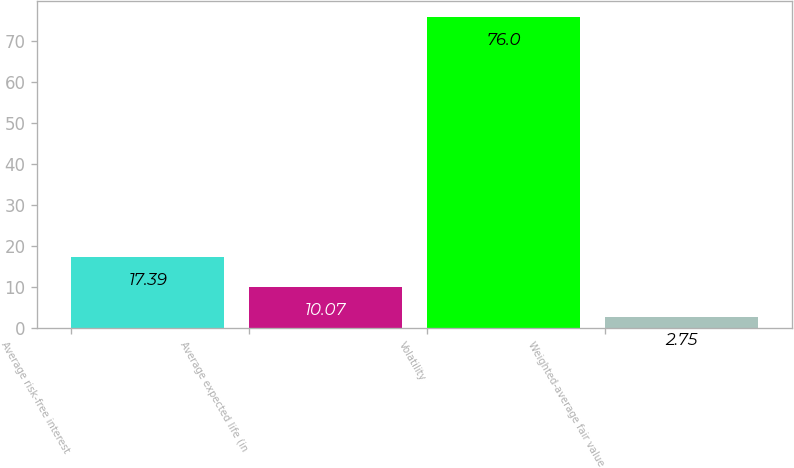<chart> <loc_0><loc_0><loc_500><loc_500><bar_chart><fcel>Average risk-free interest<fcel>Average expected life (in<fcel>Volatility<fcel>Weighted-average fair value<nl><fcel>17.39<fcel>10.07<fcel>76<fcel>2.75<nl></chart> 